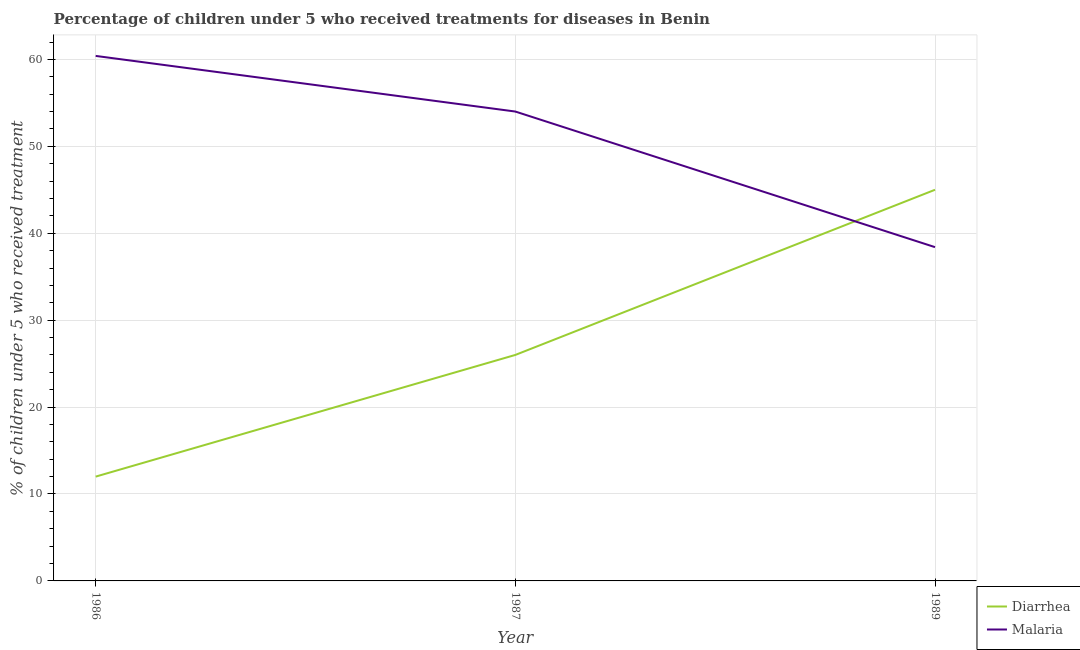What is the percentage of children who received treatment for malaria in 1989?
Make the answer very short. 38.4. Across all years, what is the maximum percentage of children who received treatment for malaria?
Ensure brevity in your answer.  60.4. Across all years, what is the minimum percentage of children who received treatment for diarrhoea?
Your response must be concise. 12. In which year was the percentage of children who received treatment for diarrhoea minimum?
Provide a succinct answer. 1986. What is the total percentage of children who received treatment for malaria in the graph?
Make the answer very short. 152.8. What is the difference between the percentage of children who received treatment for diarrhoea in 1986 and that in 1989?
Your answer should be compact. -33. What is the average percentage of children who received treatment for diarrhoea per year?
Keep it short and to the point. 27.67. In how many years, is the percentage of children who received treatment for malaria greater than 42 %?
Give a very brief answer. 2. What is the ratio of the percentage of children who received treatment for diarrhoea in 1986 to that in 1987?
Ensure brevity in your answer.  0.46. Is the percentage of children who received treatment for diarrhoea in 1986 less than that in 1989?
Provide a succinct answer. Yes. Is the percentage of children who received treatment for diarrhoea strictly less than the percentage of children who received treatment for malaria over the years?
Your answer should be compact. No. How many years are there in the graph?
Provide a short and direct response. 3. Are the values on the major ticks of Y-axis written in scientific E-notation?
Offer a terse response. No. What is the title of the graph?
Your answer should be compact. Percentage of children under 5 who received treatments for diseases in Benin. What is the label or title of the Y-axis?
Your answer should be compact. % of children under 5 who received treatment. What is the % of children under 5 who received treatment of Malaria in 1986?
Give a very brief answer. 60.4. What is the % of children under 5 who received treatment in Diarrhea in 1987?
Ensure brevity in your answer.  26. What is the % of children under 5 who received treatment in Malaria in 1989?
Make the answer very short. 38.4. Across all years, what is the maximum % of children under 5 who received treatment in Malaria?
Ensure brevity in your answer.  60.4. Across all years, what is the minimum % of children under 5 who received treatment of Malaria?
Your answer should be compact. 38.4. What is the total % of children under 5 who received treatment of Diarrhea in the graph?
Provide a short and direct response. 83. What is the total % of children under 5 who received treatment of Malaria in the graph?
Provide a succinct answer. 152.8. What is the difference between the % of children under 5 who received treatment of Diarrhea in 1986 and that in 1987?
Give a very brief answer. -14. What is the difference between the % of children under 5 who received treatment in Diarrhea in 1986 and that in 1989?
Your response must be concise. -33. What is the difference between the % of children under 5 who received treatment in Malaria in 1987 and that in 1989?
Offer a terse response. 15.6. What is the difference between the % of children under 5 who received treatment of Diarrhea in 1986 and the % of children under 5 who received treatment of Malaria in 1987?
Provide a short and direct response. -42. What is the difference between the % of children under 5 who received treatment in Diarrhea in 1986 and the % of children under 5 who received treatment in Malaria in 1989?
Your answer should be compact. -26.4. What is the average % of children under 5 who received treatment of Diarrhea per year?
Offer a very short reply. 27.67. What is the average % of children under 5 who received treatment of Malaria per year?
Your answer should be compact. 50.93. In the year 1986, what is the difference between the % of children under 5 who received treatment in Diarrhea and % of children under 5 who received treatment in Malaria?
Ensure brevity in your answer.  -48.4. In the year 1987, what is the difference between the % of children under 5 who received treatment in Diarrhea and % of children under 5 who received treatment in Malaria?
Your answer should be very brief. -28. What is the ratio of the % of children under 5 who received treatment in Diarrhea in 1986 to that in 1987?
Make the answer very short. 0.46. What is the ratio of the % of children under 5 who received treatment of Malaria in 1986 to that in 1987?
Make the answer very short. 1.12. What is the ratio of the % of children under 5 who received treatment in Diarrhea in 1986 to that in 1989?
Give a very brief answer. 0.27. What is the ratio of the % of children under 5 who received treatment of Malaria in 1986 to that in 1989?
Provide a short and direct response. 1.57. What is the ratio of the % of children under 5 who received treatment in Diarrhea in 1987 to that in 1989?
Make the answer very short. 0.58. What is the ratio of the % of children under 5 who received treatment in Malaria in 1987 to that in 1989?
Provide a short and direct response. 1.41. 